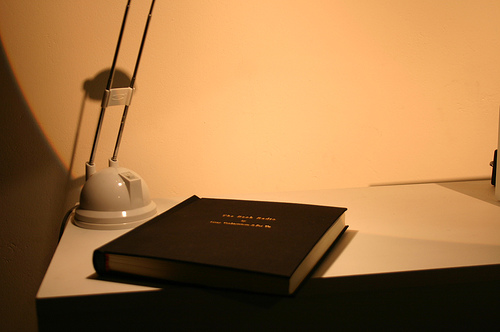<image>
Is there a book under the light? Yes. The book is positioned underneath the light, with the light above it in the vertical space. Is there a book on the table? Yes. Looking at the image, I can see the book is positioned on top of the table, with the table providing support. Is the book to the right of the table? No. The book is not to the right of the table. The horizontal positioning shows a different relationship. 